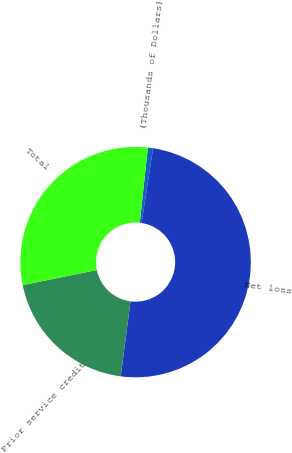Convert chart. <chart><loc_0><loc_0><loc_500><loc_500><pie_chart><fcel>(Thousands of Dollars)<fcel>Net loss<fcel>Prior service credit<fcel>Total<nl><fcel>0.73%<fcel>49.63%<fcel>19.74%<fcel>29.9%<nl></chart> 